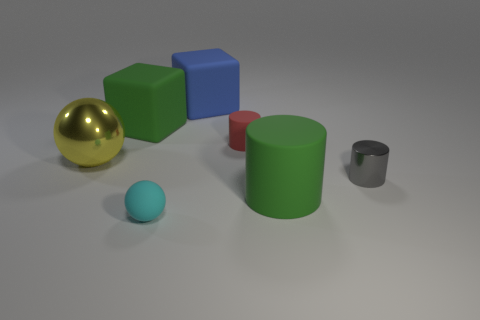Subtract all red cylinders. How many cylinders are left? 2 Add 1 cyan rubber things. How many objects exist? 8 Subtract all gray cylinders. How many cylinders are left? 2 Subtract all cubes. How many objects are left? 5 Subtract 1 cubes. How many cubes are left? 1 Add 7 small matte cylinders. How many small matte cylinders are left? 8 Add 4 blue cubes. How many blue cubes exist? 5 Subtract 1 green blocks. How many objects are left? 6 Subtract all brown cylinders. Subtract all cyan blocks. How many cylinders are left? 3 Subtract all large green objects. Subtract all cyan rubber balls. How many objects are left? 4 